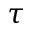Convert formula to latex. <formula><loc_0><loc_0><loc_500><loc_500>\tau</formula> 